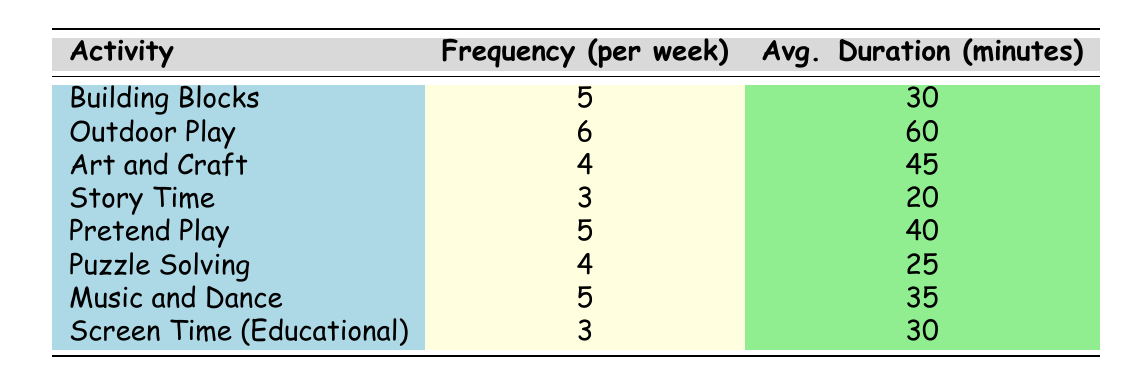What activity has the highest frequency of playtime? From the table, Outdoor Play has a frequency of 6 per week, which is higher than the other activities.
Answer: Outdoor Play How many activities have a frequency of 5 per week? The activities with a frequency of 5 per week are Building Blocks, Pretend Play, and Music and Dance, making a total of 3 activities.
Answer: 3 What is the average duration of Story Time? The average duration of Story Time is 20 minutes as listed in the table.
Answer: 20 minutes Which activity has the longest average duration? Outdoor Play has the longest average duration at 60 minutes, more than any other activity listed in the table.
Answer: 60 minutes Is the frequency of Puzzle Solving greater than that of Art and Craft? Puzzle Solving has a frequency of 4 per week while Art and Craft also has a frequency of 4 per week, so the statement is false.
Answer: No What is the total frequency per week for all activities listed? To find the total frequency, we add the frequencies of all activities: 5 + 6 + 4 + 3 + 5 + 4 + 5 + 3 = 35.
Answer: 35 What is the average frequency of playtime activities? To calculate the average frequency, we take the total frequency (35) and divide it by the number of activities (8): 35/8 = 4.375.
Answer: 4.375 Which activities have an average duration of more than 35 minutes? The activities with an average duration over 35 minutes are Outdoor Play (60), Art and Craft (45), and Pretend Play (40).
Answer: 3 activities How does Music and Dance's frequency compare to Screen Time (Educational)? Music and Dance has a frequency of 5 per week, while Screen Time (Educational) has a frequency of 3 per week, indicating that Music and Dance is more frequent.
Answer: Yes 